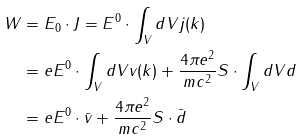Convert formula to latex. <formula><loc_0><loc_0><loc_500><loc_500>W & = E _ { 0 } \cdot J = E ^ { 0 } \cdot \int _ { V } d V { j } ( { k } ) \\ & = e E ^ { 0 } \cdot \int _ { V } d V { v } ( { k } ) + \frac { 4 \pi e ^ { 2 } } { m c ^ { 2 } } { S } \cdot \int _ { V } d V { d } \\ & = e E ^ { 0 } \cdot \bar { v } + \frac { 4 \pi e ^ { 2 } } { m c ^ { 2 } } { S } \cdot \bar { d } \\</formula> 